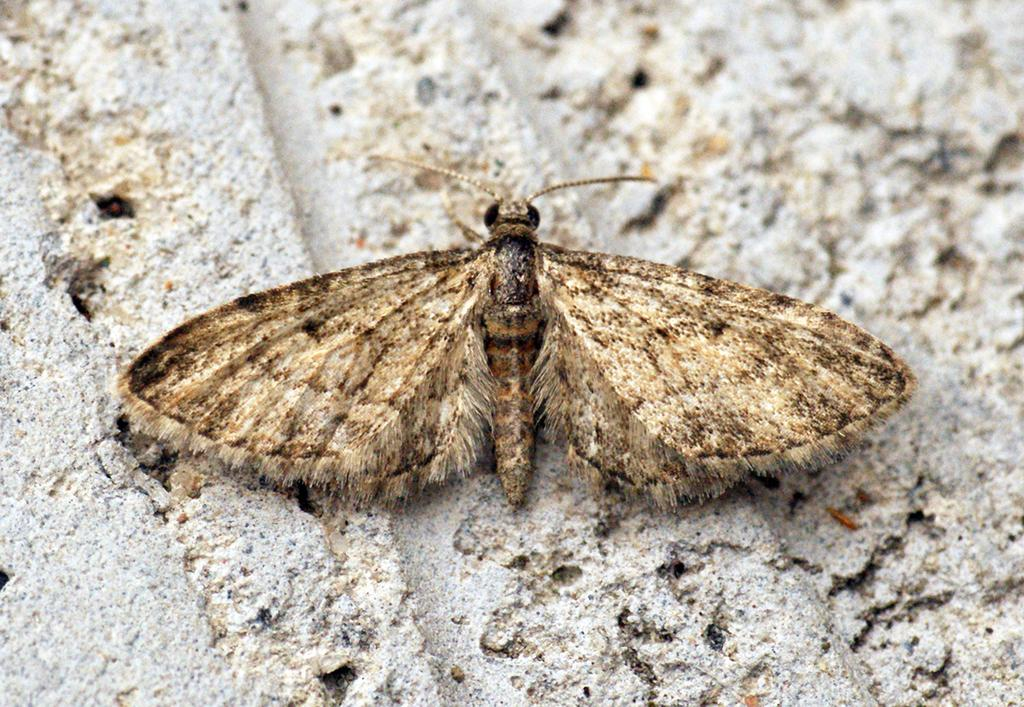What type of animal is depicted in the image? There is a butterfly represented in the image. What type of breakfast is being served in the image? There is no breakfast depicted in the image; it features a butterfly. What is the profit margin for the butterfly in the image? There is no indication of profit or financial transactions in the image, as it simply represents a butterfly. 